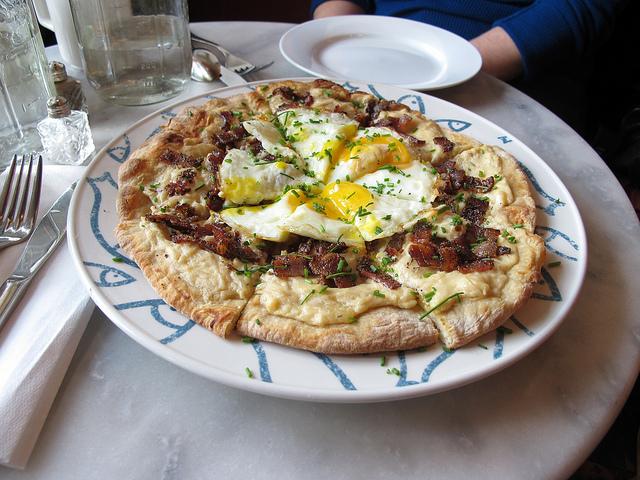What color is the plate?
Give a very brief answer. White and blue. What kind of food is on the plate?
Concise answer only. Pizza. What kind of pizza is this?
Answer briefly. Breakfast. 